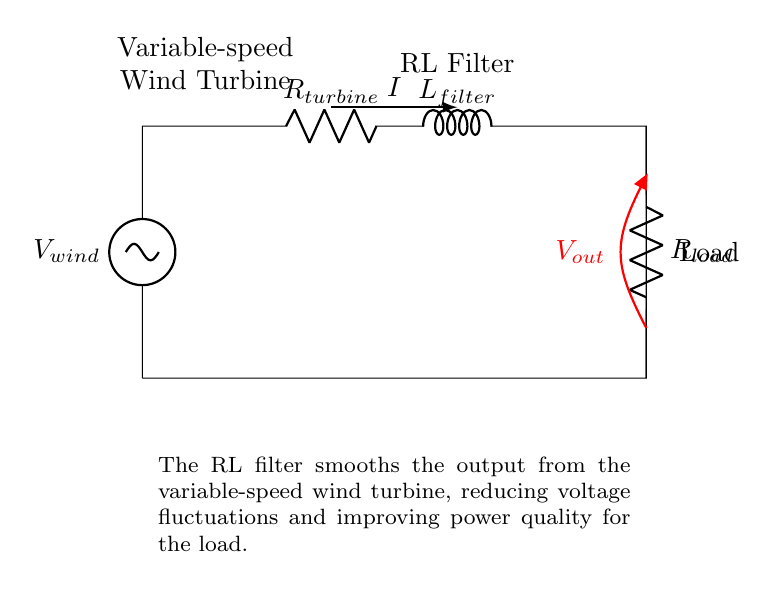What is the function of the resistor in this circuit? The function of the resistor is to limit the current flowing through the circuit and to help with the voltage drop across the load. In this diagram, it is labeled as R load.
Answer: Limit current What does L filter represent? L filter represents an inductor that is used to smooth the output voltage from the wind turbine by reducing voltage fluctuations. Inductors store energy and oppose changes in current.
Answer: Inductor What is the output voltage measurement point labeled as? The output voltage measurement point is indicated in the diagram with a label showing V out, which denotes the voltage across the load resistor.
Answer: V out How does the RL filter improve power quality? The RL filter improves power quality by damping the fluctuations in the output voltage from the variable-speed wind turbine, resulting in a more stable and smoother output for the load. This is achieved by the inductor's ability to resist rapid changes in current.
Answer: Damps voltage fluctuations What happens to the current as it passes through the RL filter? As the current passes through the RL filter, it encounters both resistance and inductance, which together cause a phase shift between the voltage and current and limit the transient response of the circuit, leading to a smoother current waveform.
Answer: Smoother current waveform What type of circuit is represented by the RL filter? The circuit is a second-order low-pass filter because it uses a resistor and an inductor to attenuate high-frequency noise and allow lower frequency signals to pass through, making it effective for smoothing applications.
Answer: Low-pass filter What is the role of the variable-speed wind turbine in this circuit? The variable-speed wind turbine generates electrical power by converting kinetic energy from wind into electrical energy, which is then processed by the RL filter to stabilize the output before reaching the load.
Answer: Generate power 